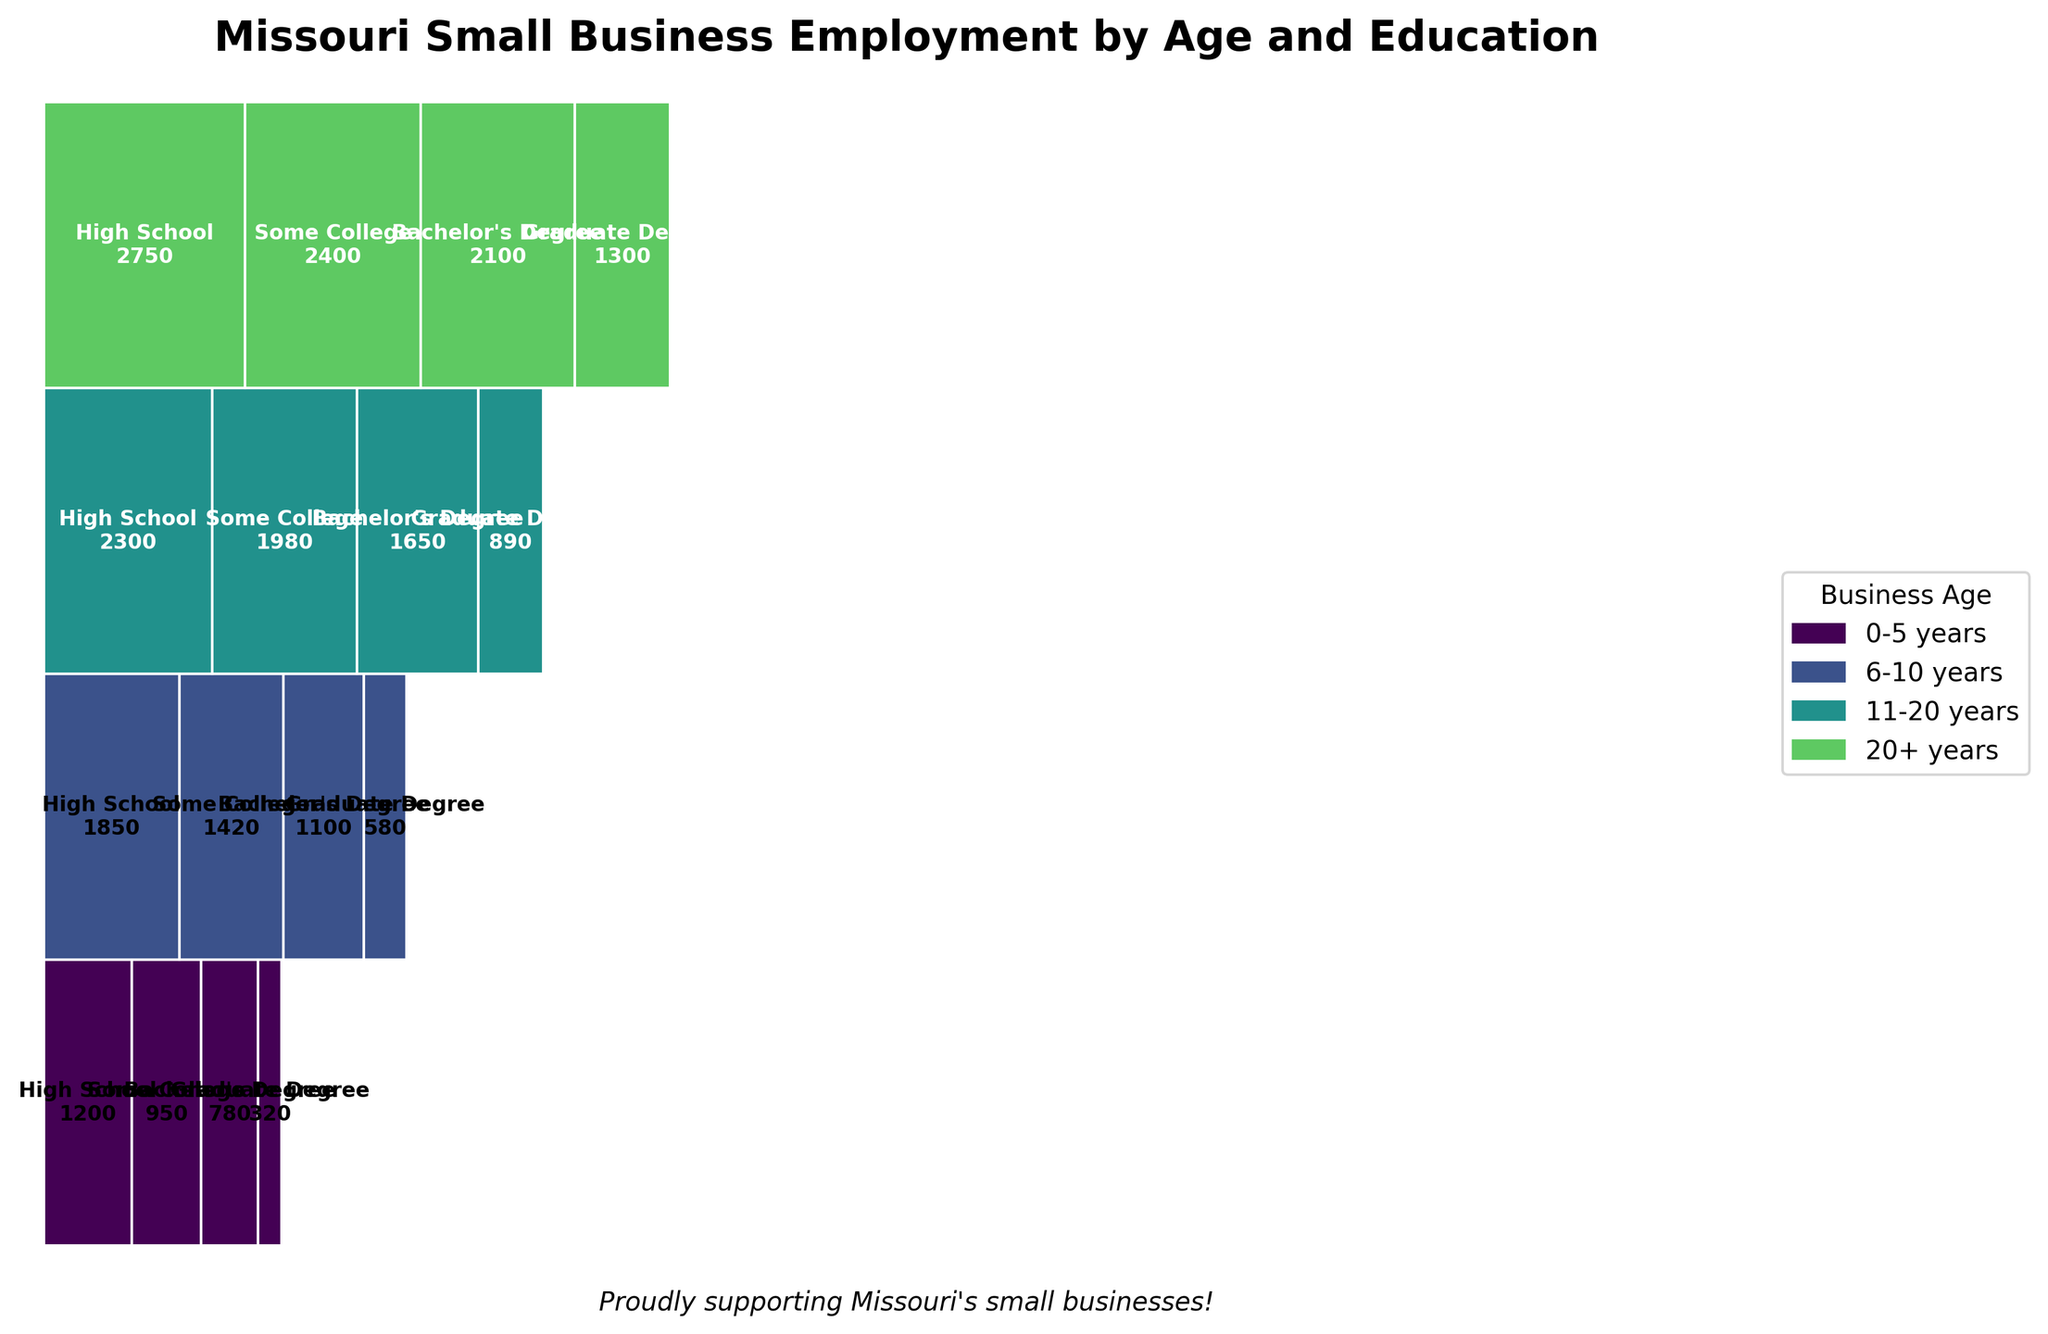what is the title of the plot? The title is typically located at the top of the plot. In this case, it reads "Missouri Small Business Employment by Age and Education".
Answer: Missouri Small Business Employment by Age and Education Which age group has the most employees with Some College education? To find this, look at the sections labeled "Some College" for each age group and compare their sizes. The 20+ years group has the widest section for Some College.
Answer: 20+ years How many employees have a Graduate Degree in businesses aged 6-10 years? Locate the segment for businesses aged 6-10 years and then find the part of that segment labeled "Graduate Degree". The segment has a value of 580 employees.
Answer: 580 Which has more employees with a Bachelor's Degree: businesses aged 11-20 years, or businesses aged 20+ years? Compare the width of the tiles labeled "Bachelor's Degree" in these two age groups. The 20+ years group is wider.
Answer: 20+ years What is the total number of employees in businesses aged 0-5 years and 6-10 years combined? Sum the number of employees from the "0-5 years" and "6-10 years" age groups. It's 1200 + 950 + 780 + 320 = 3250 and 1850 + 1420 + 1100 + 580 = 4950, respectively. 3250 + 4950 = 8200
Answer: 8200 Which education level has the least number of employees in businesses aged 20+ years? Look at the segments within the 20+ years group and find the smallest one. The Graduate Degree segment is the smallest.
Answer: Graduate Degree Are there more employees with a High School education or a Bachelor's Degree in businesses aged 11-20 years? Compare the tiles for "High School" and "Bachelor's Degree" within the 11-20 years group. High School is larger.
Answer: High School How many employees with some College education are there in all businesses combined? Sum the employees with Some College education across all age groups: 950 (0-5 years) + 1420 (6-10 years) + 1980 (11-20 years) + 2400 (20+ years). Total: (950+1420+1980+2400=6750).
Answer: 6750 Is the proportion of employees with Graduate Degrees larger in newer (0-5 years) or older (20+ years) businesses? Compare the proportions of the Graduate Degree sections between the newer (0-5 years) and older (20+ years) businesses. The section for 0-5 years is smaller than the section for 20+ years.
Answer: 20+ years 